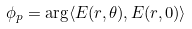Convert formula to latex. <formula><loc_0><loc_0><loc_500><loc_500>\phi _ { p } = \arg \langle E ( r , \theta ) , E ( r , 0 ) \rangle</formula> 